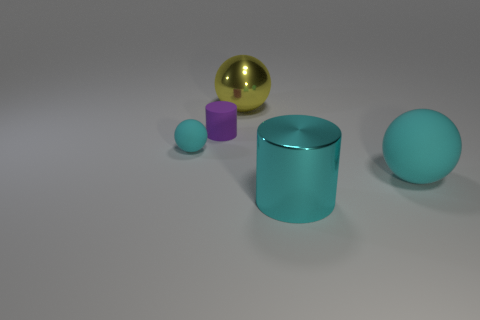Does the big rubber object have the same color as the big metal cylinder?
Provide a short and direct response. Yes. There is a cyan ball that is on the right side of the small thing behind the cyan matte object that is on the left side of the large rubber ball; how big is it?
Your answer should be compact. Large. What is the color of the sphere that is both to the right of the small rubber cylinder and left of the cyan shiny object?
Offer a very short reply. Yellow. There is a cyan rubber object on the left side of the tiny purple cylinder; what size is it?
Your response must be concise. Small. What number of cyan objects are the same material as the small purple cylinder?
Your answer should be very brief. 2. The small matte thing that is the same color as the big shiny cylinder is what shape?
Your response must be concise. Sphere. Is the shape of the big metal object on the left side of the cyan metal cylinder the same as  the tiny purple rubber thing?
Offer a very short reply. No. What color is the large object that is made of the same material as the small cylinder?
Offer a terse response. Cyan. There is a big thing that is in front of the cyan matte thing in front of the tiny cyan rubber thing; is there a large metal thing that is in front of it?
Your answer should be compact. No. The big yellow object has what shape?
Provide a short and direct response. Sphere. 